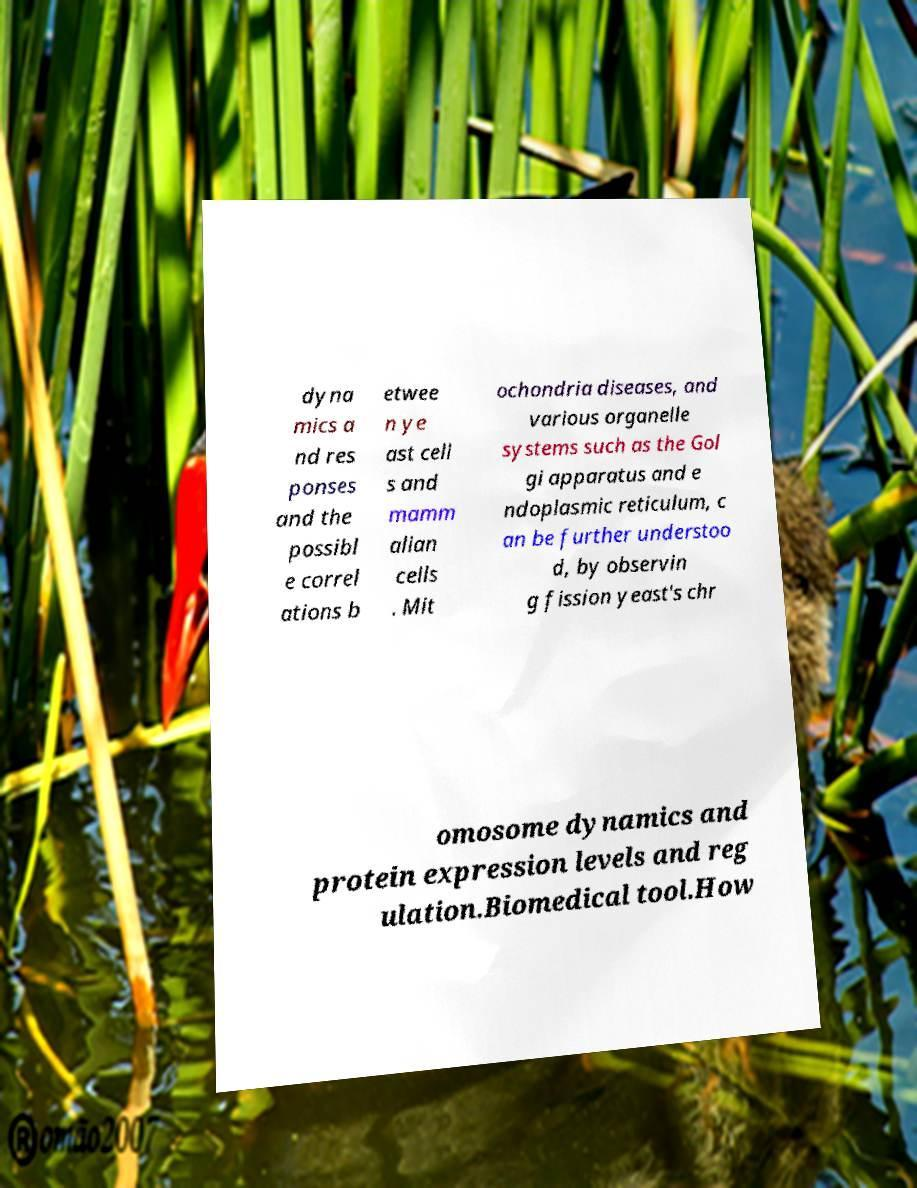Could you extract and type out the text from this image? dyna mics a nd res ponses and the possibl e correl ations b etwee n ye ast cell s and mamm alian cells . Mit ochondria diseases, and various organelle systems such as the Gol gi apparatus and e ndoplasmic reticulum, c an be further understoo d, by observin g fission yeast's chr omosome dynamics and protein expression levels and reg ulation.Biomedical tool.How 